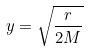<formula> <loc_0><loc_0><loc_500><loc_500>y = \sqrt { \frac { r } { 2 M } }</formula> 